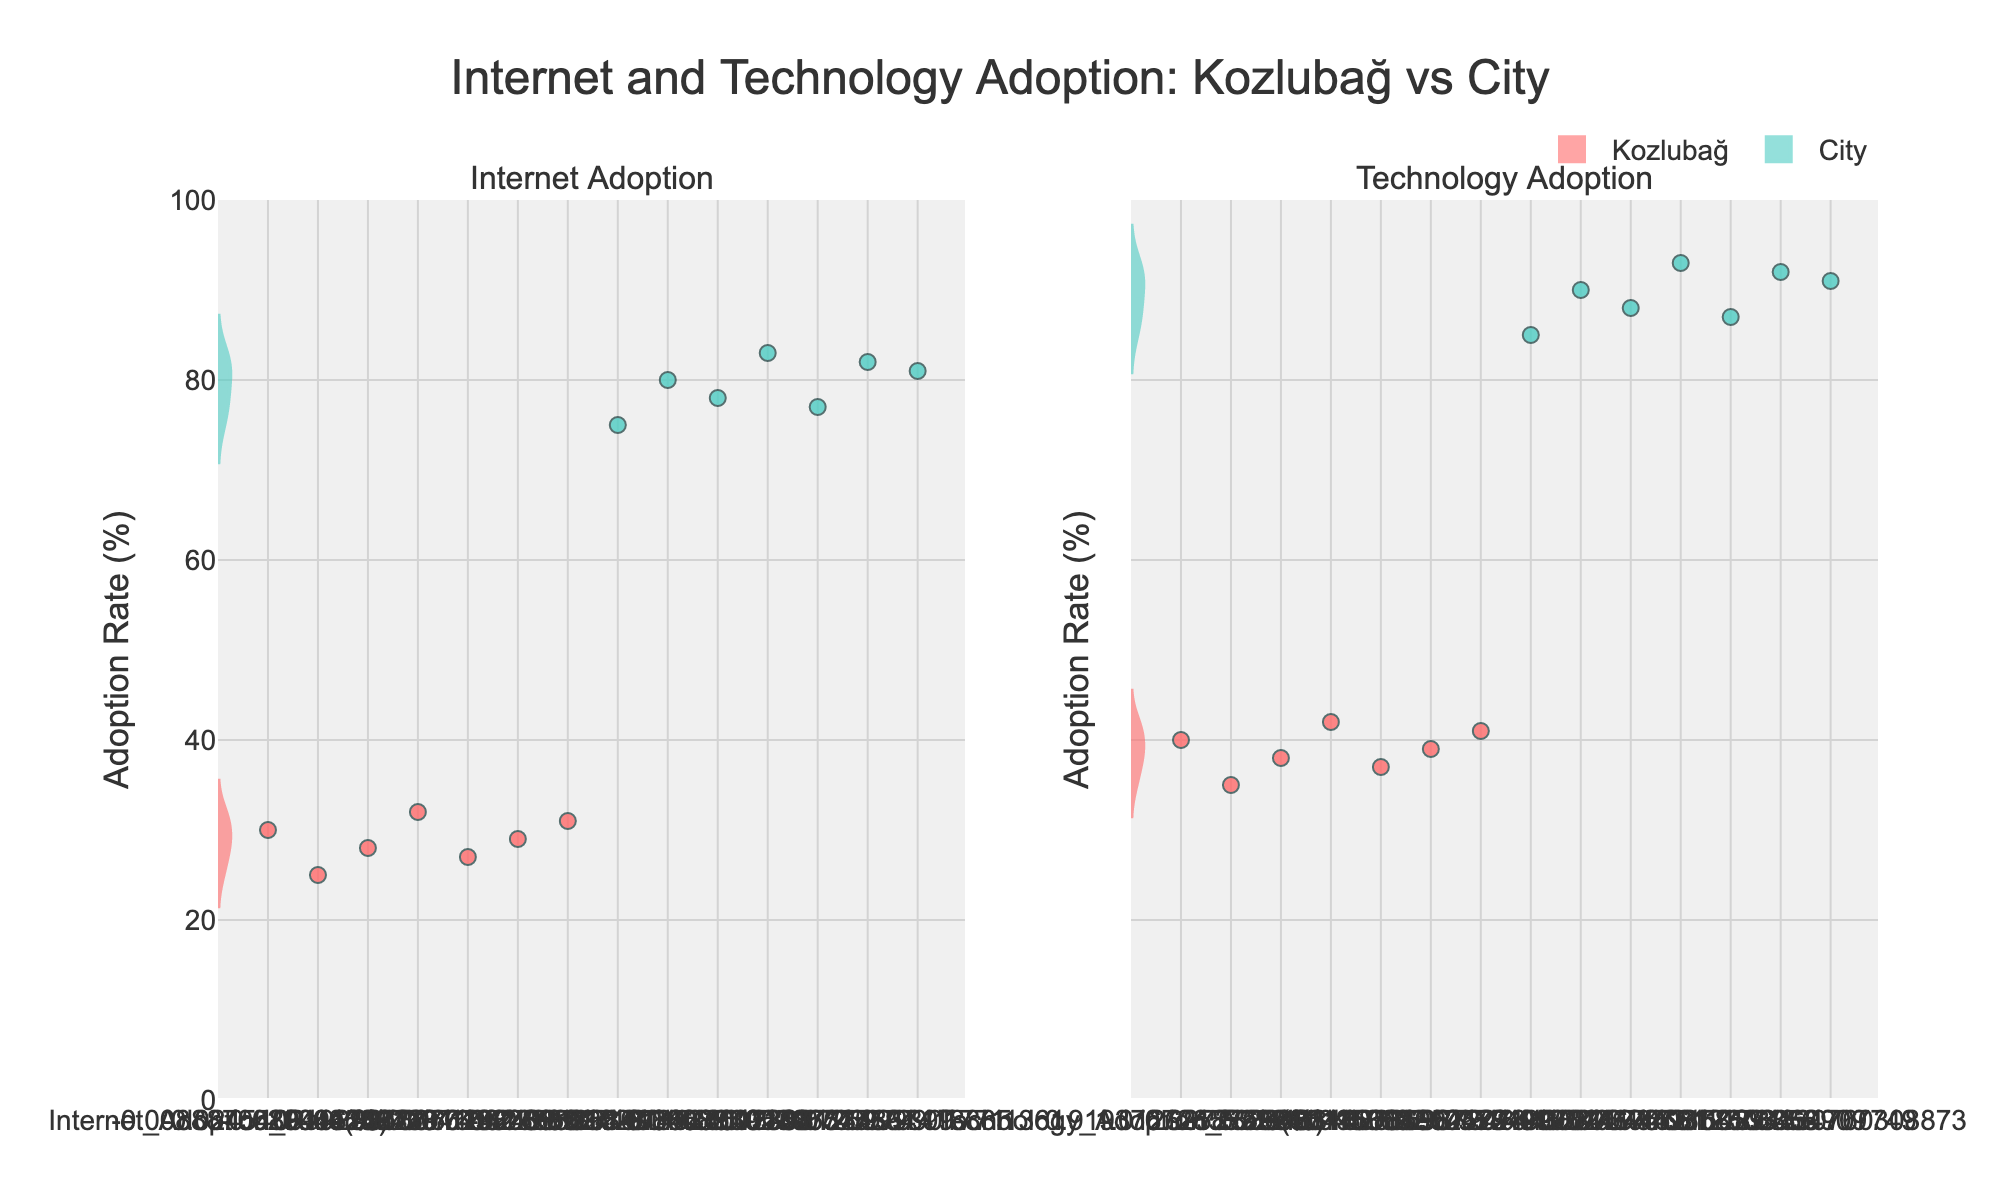What are the titles of the subplots? The titles of the subplots can be seen on top of each violin chart. They are labeled "Internet Adoption" and "Technology Adoption".
Answer: "Internet Adoption" and "Technology Adoption" Which location appears to have a higher average internet adoption rate? The violin plot mean lines indicate the average adoption rate. It is clear that the mean line in the city subplot is higher compared to the one for Kozlubağ.
Answer: City How many users are represented from Kozlubağ? Each jittered point represents a user. By counting the points on the Kozlubağ side of both the Internet and Technology subplots, we can see there are 7 points.
Answer: 7 Which location shows a more concentrated distribution of technology adoption rates? The width of the violin plot indicates the density of the data. The City subplot is narrower compared to Kozlubağ, indicating a more concentrated distribution.
Answer: City What is the range of the technology adoption rate in Kozlubağ? By observing the extent of the jittered points in the Kozlubağ plot for technology adoption, the rates range from about 35% to 42%.
Answer: 35%-42% What is the color used for the Kozlubağ data points? The color used in the violin plots and jittered points for Kozlubağ is a shade of red.
Answer: Red What is the difference between the highest internet adoption rates in Kozlubağ and the City? Identify the highest point on the jittered plot for Kozlubağ (32%) and the City (83%). Subtracting these, we get: 83% - 32%.
Answer: 51% Which location demonstrates a greater variance in internet adoption rates? By observing the violin plots’ widths, Kozlubağ’s plot is wider than the City's plot, indicating greater variance.
Answer: Kozlubağ What is the mean technology adoption rate in the City? The mean line on the City's violin plot for technology adoption aligns around 90%, therefore the mean technology adoption rate for the city is 90%.
Answer: 90% Is the internet adoption rate tightly clustered for inhabitants of the City? Yes, in the City's subplot for internet adoption, the violin plot is quite narrow, indicating that the data points are tightly clustered.
Answer: Yes 